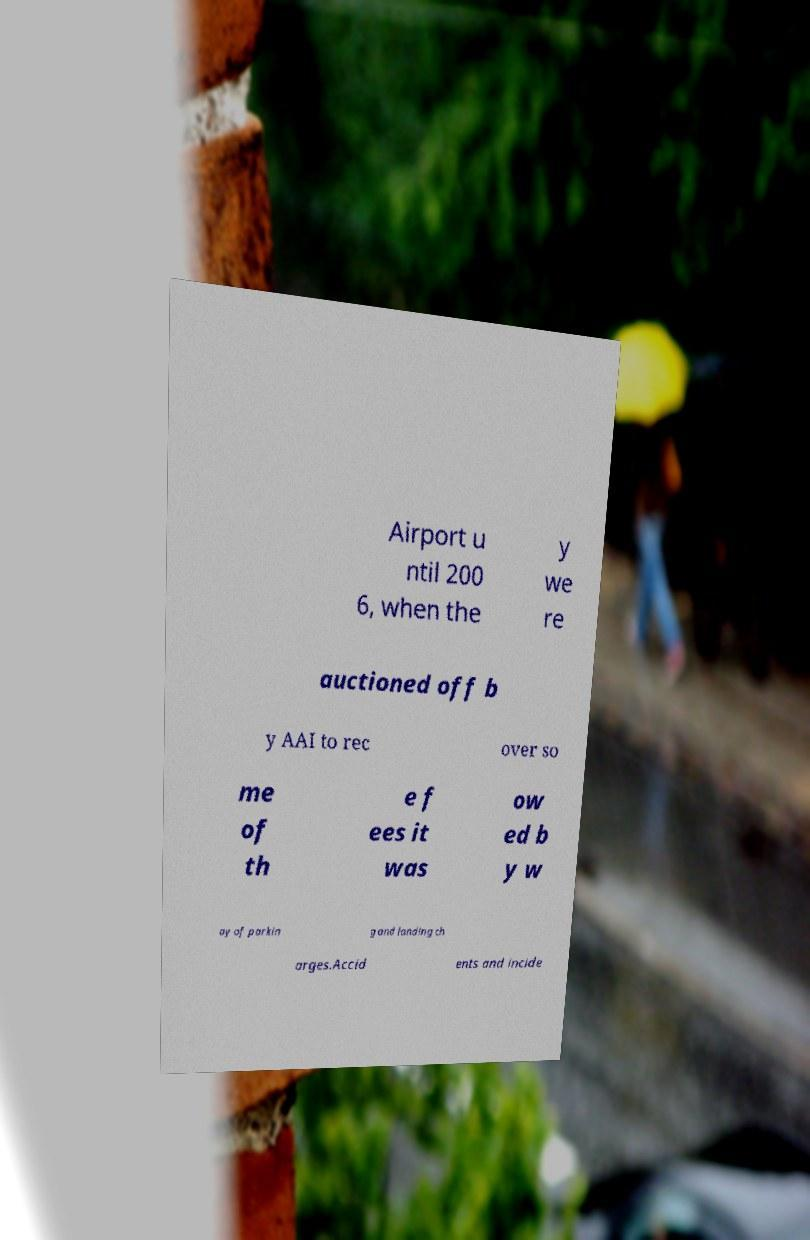There's text embedded in this image that I need extracted. Can you transcribe it verbatim? Airport u ntil 200 6, when the y we re auctioned off b y AAI to rec over so me of th e f ees it was ow ed b y w ay of parkin g and landing ch arges.Accid ents and incide 